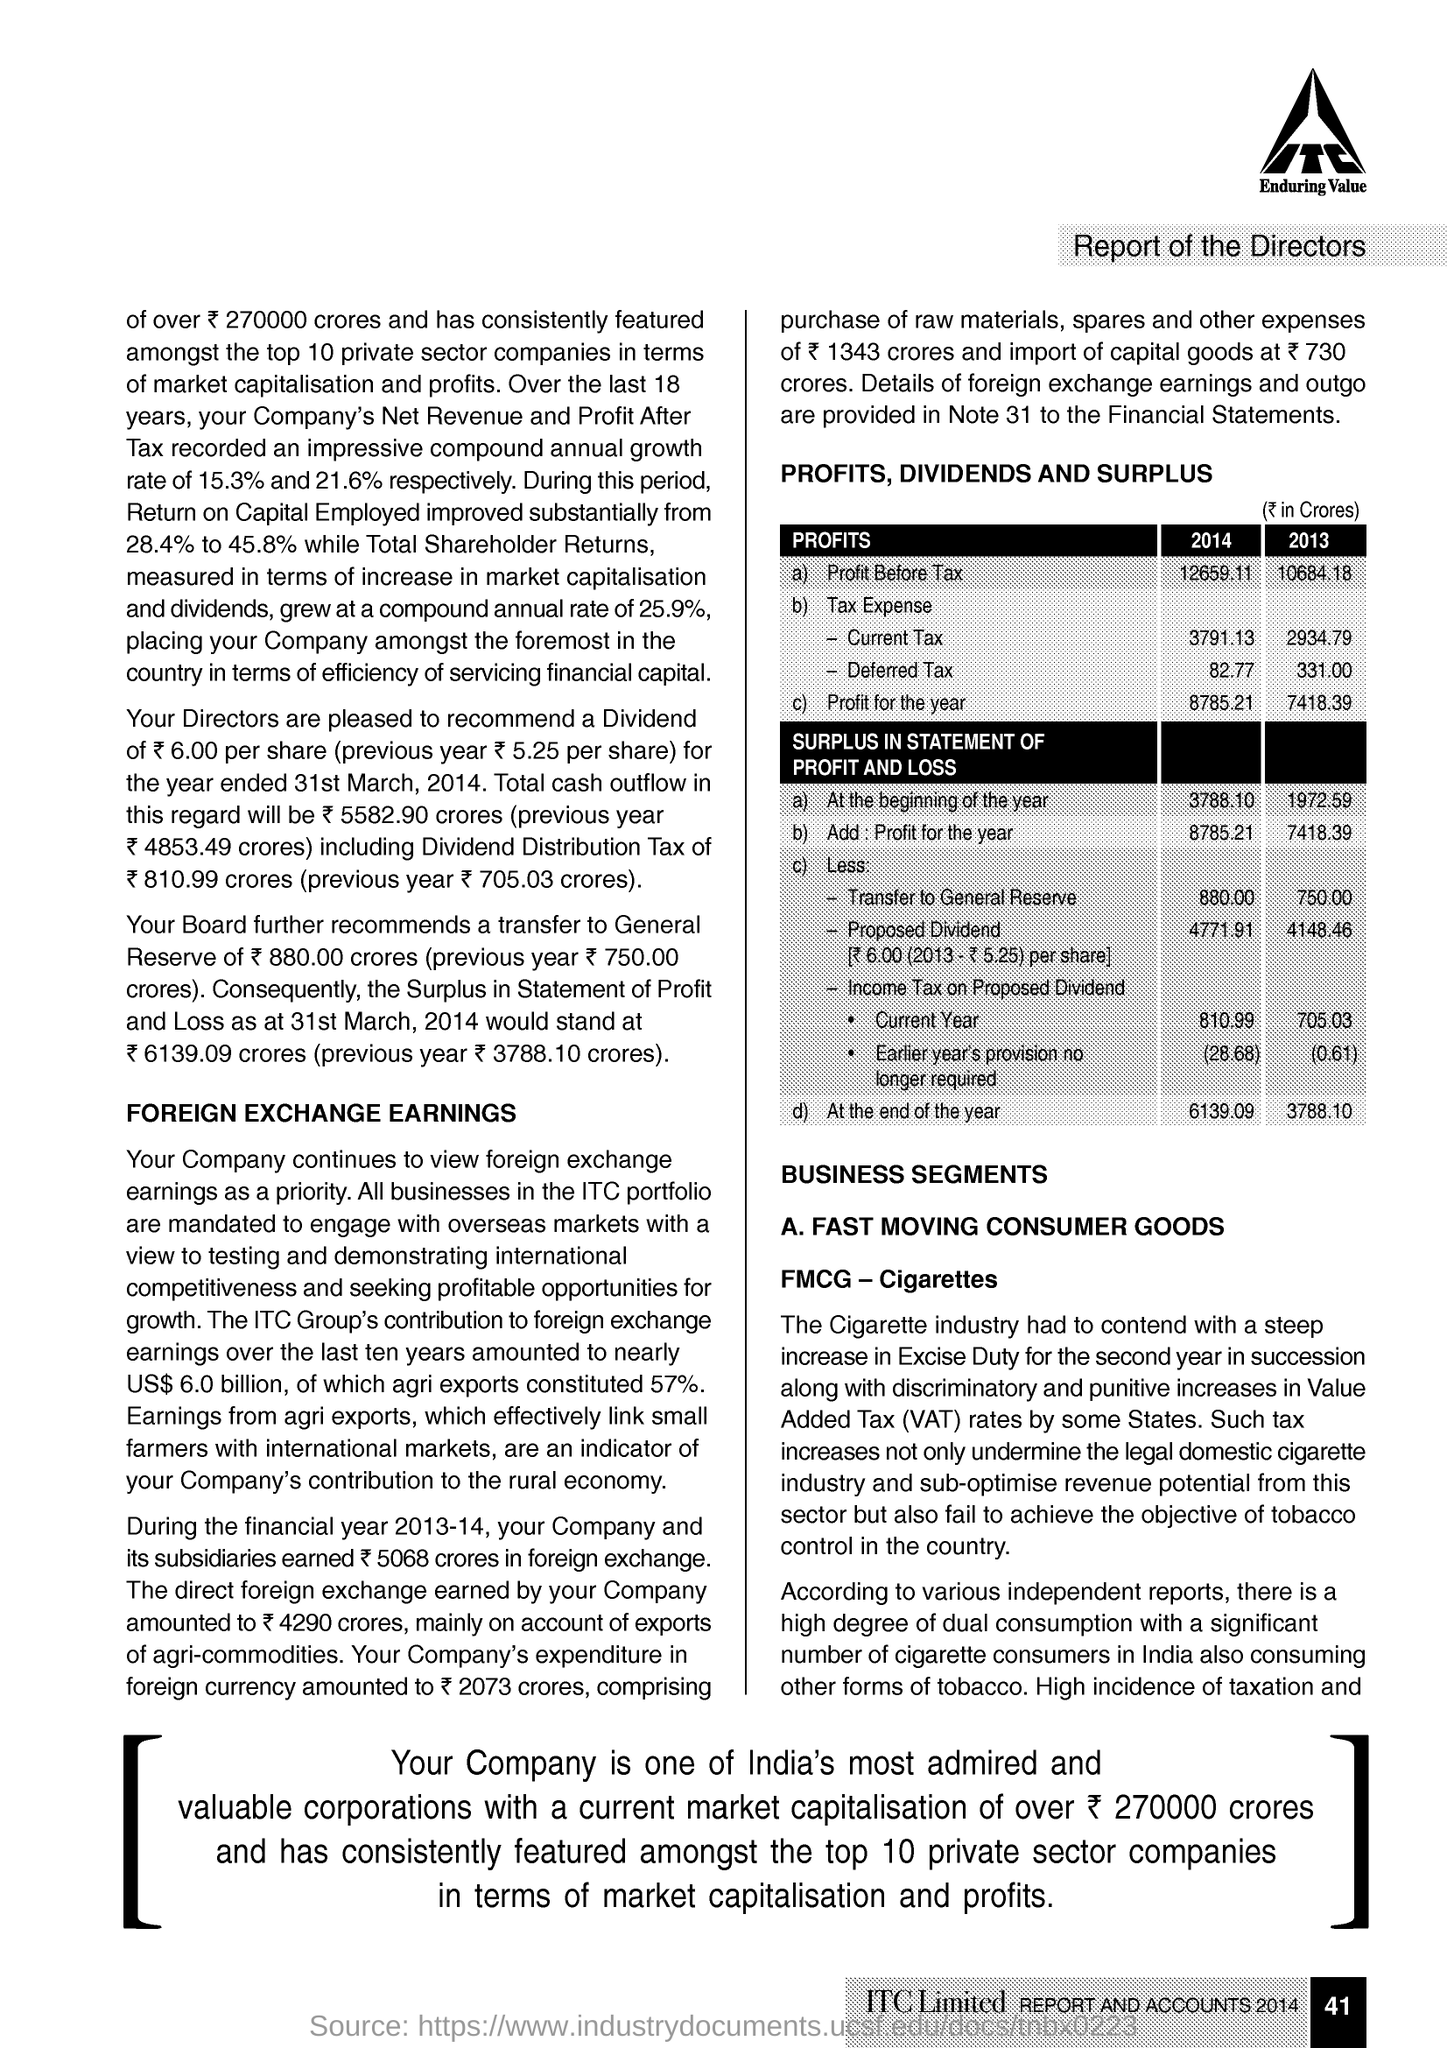What is the Profit Before Tax in 2014 ?
Give a very brief answer. 12659.11. What is the Fullform of FMCG ?
Provide a short and direct response. FAST MOVING CONSUMER GOODS. What is the Profit for the year in 2013 ?
Your answer should be very brief. 7418.39. What is the Fullform of VAT ?
Keep it short and to the point. Value added tax. 